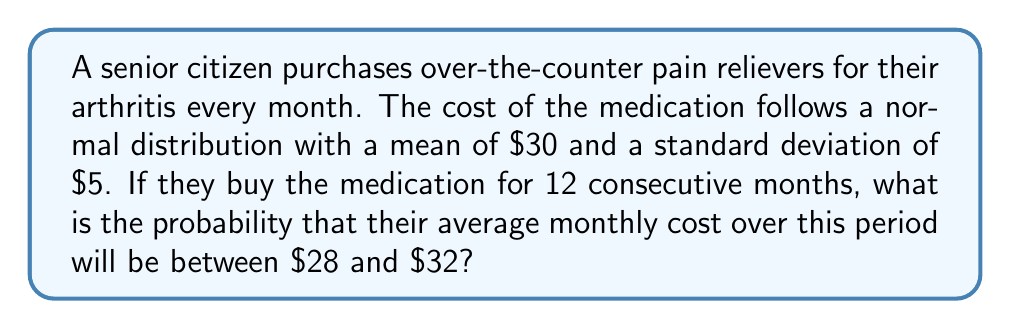Solve this math problem. To solve this problem, we'll use the properties of the sampling distribution of the mean.

1) First, let's identify the given information:
   - The cost follows a normal distribution
   - Mean (μ) = $30
   - Standard deviation (σ) = $5
   - Number of months (n) = 12
   - We're looking for the probability that the average cost is between $28 and $32

2) The sampling distribution of the mean has the following properties:
   - Its mean is equal to the population mean: $μ_{\bar{X}} = μ = $30
   - Its standard deviation (standard error) is: $σ_{\bar{X}} = \frac{σ}{\sqrt{n}} = \frac{5}{\sqrt{12}} = 1.44$

3) We need to find P($28 < \bar{X} < 32$)

4) To use the standard normal distribution, we need to standardize these values:
   $z_1 = \frac{28 - 30}{1.44} = -1.39$
   $z_2 = \frac{32 - 30}{1.44} = 1.39$

5) Now we can express our probability as:
   P($-1.39 < Z < 1.39$)

6) Using a standard normal table or calculator:
   P($Z < 1.39$) = 0.9177
   P($Z < -1.39$) = 0.0823

7) The probability we're looking for is:
   0.9177 - 0.0823 = 0.8354
Answer: The probability that the average monthly cost over 12 months will be between $28 and $32 is approximately 0.8354 or 83.54%. 